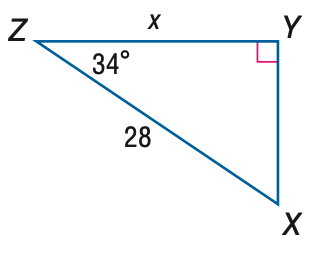Question: Find x. Round to the nearest tenth.
Choices:
A. 15.7
B. 18.9
C. 23.2
D. 33.8
Answer with the letter. Answer: C 